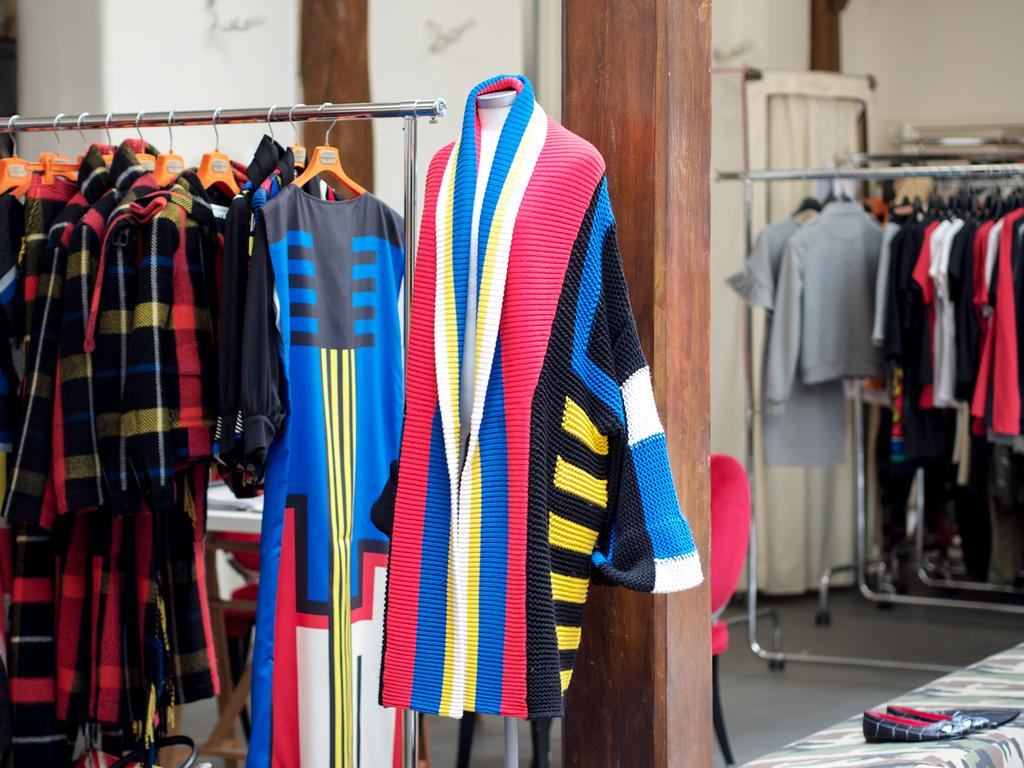What can be seen hanging on cloth stands in the image? There are clothes hanged on cloth stands in the image. What type of furniture is visible in the background of the image? There is a chair and tables in the background of the image. What can be seen on the floor in the background of the image? There is a pair of shoes in the background of the image. What is present behind the clothes and furniture in the image? There is a wall in the background of the image. What type of prose is being recited by the tiger in the image? There is no tiger present in the image, and therefore no prose being recited. 